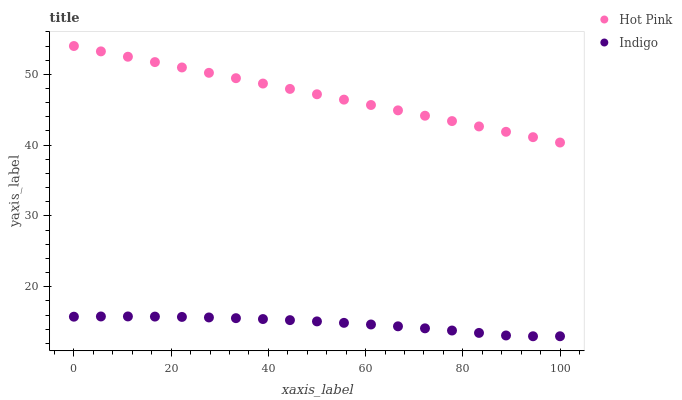Does Indigo have the minimum area under the curve?
Answer yes or no. Yes. Does Hot Pink have the maximum area under the curve?
Answer yes or no. Yes. Does Indigo have the maximum area under the curve?
Answer yes or no. No. Is Hot Pink the smoothest?
Answer yes or no. Yes. Is Indigo the roughest?
Answer yes or no. Yes. Is Indigo the smoothest?
Answer yes or no. No. Does Indigo have the lowest value?
Answer yes or no. Yes. Does Hot Pink have the highest value?
Answer yes or no. Yes. Does Indigo have the highest value?
Answer yes or no. No. Is Indigo less than Hot Pink?
Answer yes or no. Yes. Is Hot Pink greater than Indigo?
Answer yes or no. Yes. Does Indigo intersect Hot Pink?
Answer yes or no. No. 